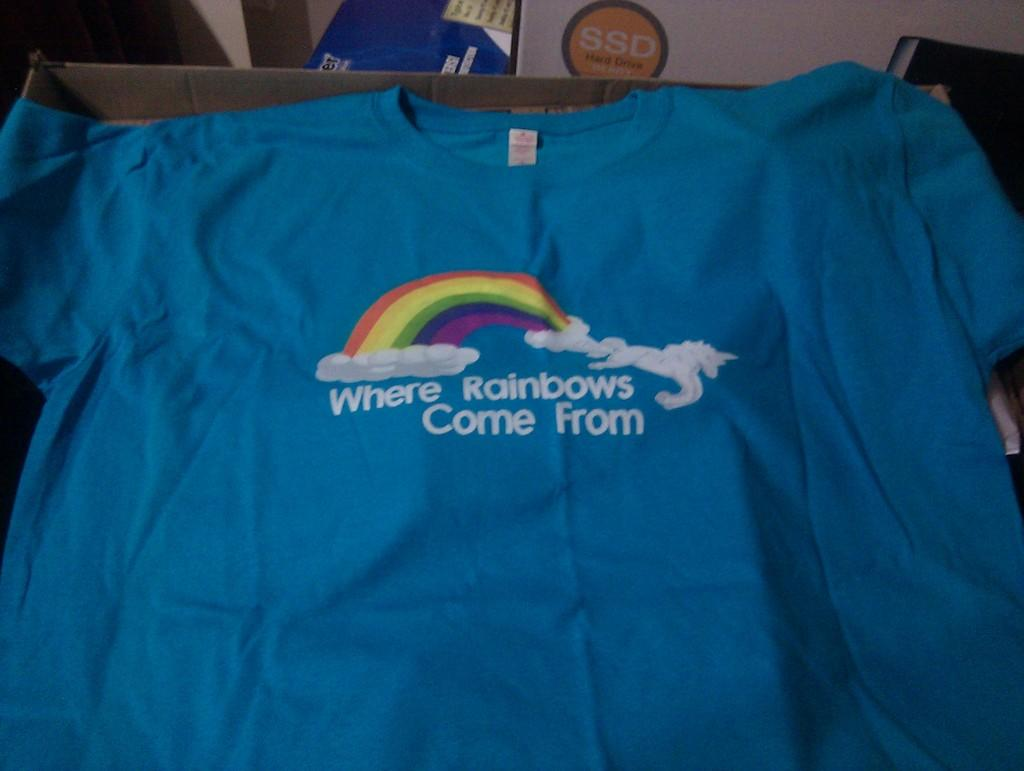What type of clothing item is visible in the image? There is a t-shirt in the image. Can you describe the background of the image? There are objects in the background of the image, but their specific details are not mentioned in the provided facts. How does the t-shirt stop the car in the image? The t-shirt does not stop the car in the image, as it is not a car-related object. 